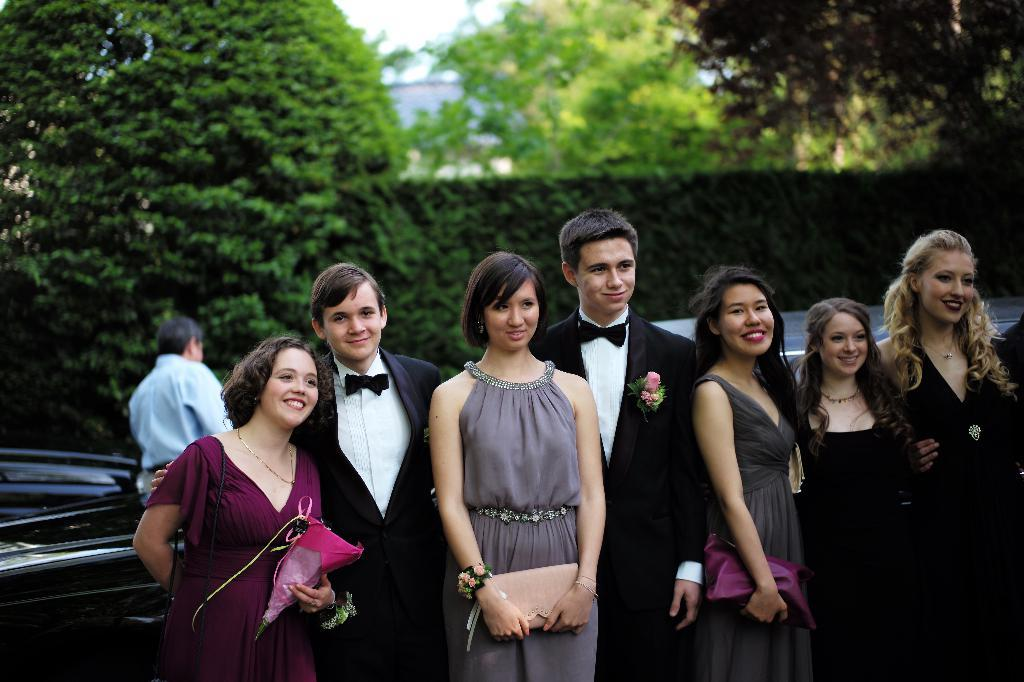What are the main subjects in the center of the image? There are persons standing in the center of the image. What can be seen in the background of the image? There are vehicles and trees in the background of the image. What is visible at the top of the image? The sky is visible at the top of the image. How many slices of pie are being balanced on the persons' heads in the image? There is no pie present in the image, and therefore no slices are being balanced on anyone's head. Is there a bike visible in the image? There is no bike mentioned or visible in the image based on the provided facts. 